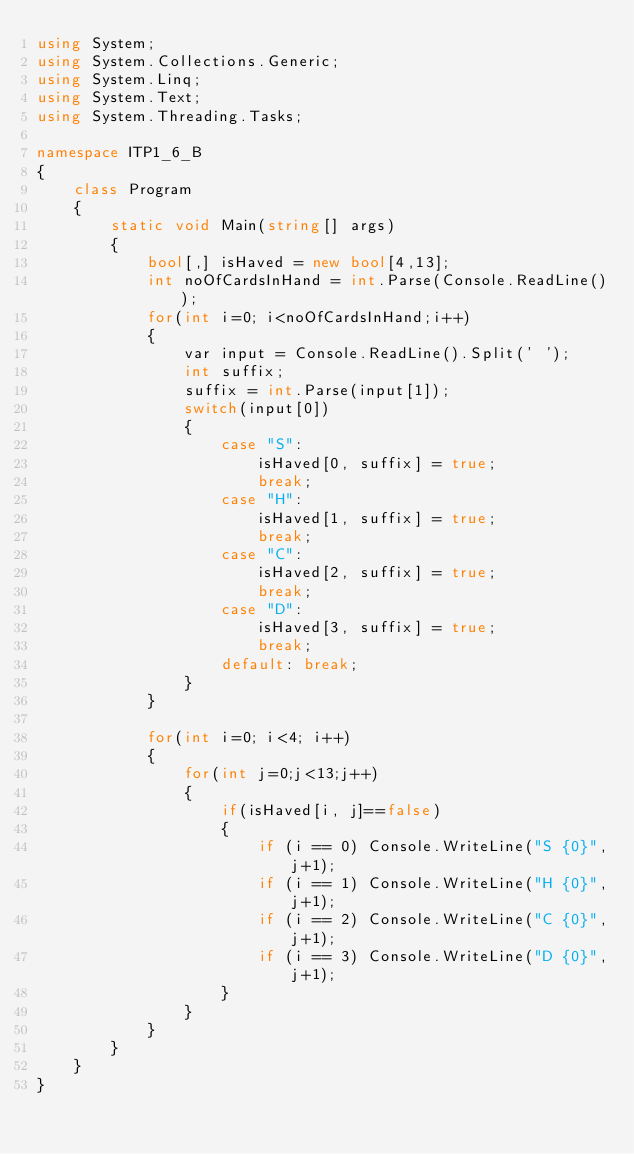<code> <loc_0><loc_0><loc_500><loc_500><_C#_>using System;
using System.Collections.Generic;
using System.Linq;
using System.Text;
using System.Threading.Tasks;

namespace ITP1_6_B
{
    class Program
    {
        static void Main(string[] args)
        {
            bool[,] isHaved = new bool[4,13];
            int noOfCardsInHand = int.Parse(Console.ReadLine());
            for(int i=0; i<noOfCardsInHand;i++)
            {
                var input = Console.ReadLine().Split(' ');
                int suffix;
                suffix = int.Parse(input[1]);
                switch(input[0])
                {
                    case "S":
                        isHaved[0, suffix] = true;
                        break;
                    case "H":
                        isHaved[1, suffix] = true;
                        break;
                    case "C":
                        isHaved[2, suffix] = true;
                        break;
                    case "D":
                        isHaved[3, suffix] = true;
                        break;
                    default: break;
                }
            }

            for(int i=0; i<4; i++)
            {
                for(int j=0;j<13;j++)
                {
                    if(isHaved[i, j]==false)
                    {
                        if (i == 0) Console.WriteLine("S {0}",j+1);
                        if (i == 1) Console.WriteLine("H {0}",j+1);
                        if (i == 2) Console.WriteLine("C {0}",j+1);
                        if (i == 3) Console.WriteLine("D {0}",j+1);
                    }
                }
            }
        }
    }
}</code> 